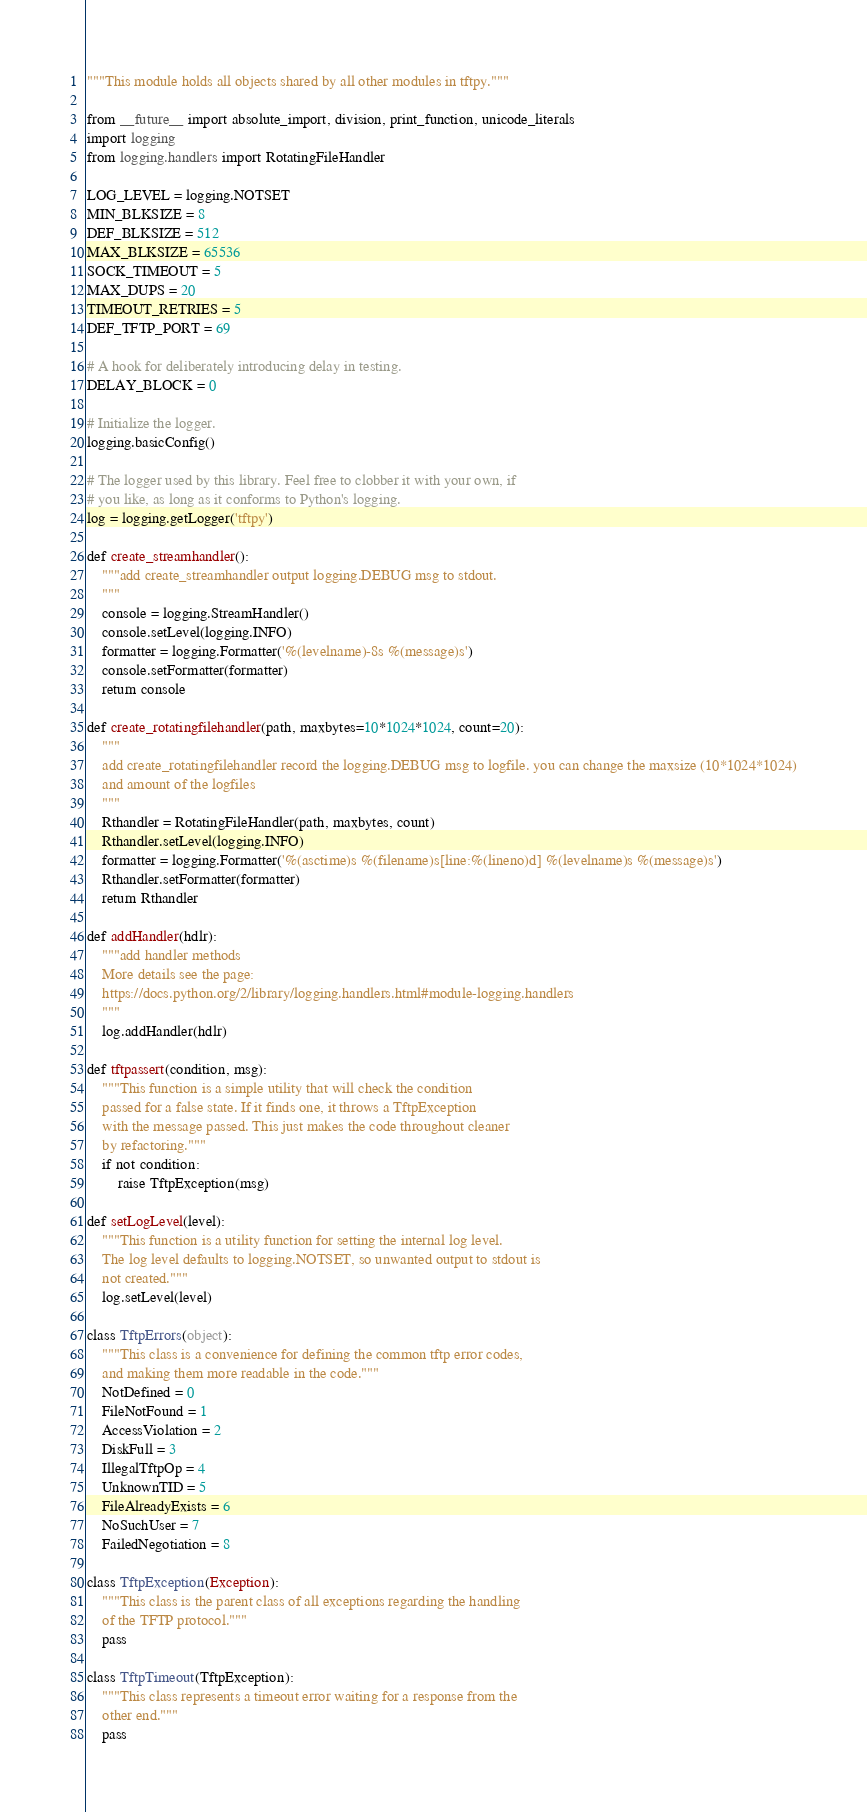Convert code to text. <code><loc_0><loc_0><loc_500><loc_500><_Python_>"""This module holds all objects shared by all other modules in tftpy."""

from __future__ import absolute_import, division, print_function, unicode_literals
import logging
from logging.handlers import RotatingFileHandler

LOG_LEVEL = logging.NOTSET
MIN_BLKSIZE = 8
DEF_BLKSIZE = 512
MAX_BLKSIZE = 65536
SOCK_TIMEOUT = 5
MAX_DUPS = 20
TIMEOUT_RETRIES = 5
DEF_TFTP_PORT = 69

# A hook for deliberately introducing delay in testing.
DELAY_BLOCK = 0

# Initialize the logger.
logging.basicConfig()

# The logger used by this library. Feel free to clobber it with your own, if
# you like, as long as it conforms to Python's logging.
log = logging.getLogger('tftpy')

def create_streamhandler():
    """add create_streamhandler output logging.DEBUG msg to stdout.
    """
    console = logging.StreamHandler()
    console.setLevel(logging.INFO)
    formatter = logging.Formatter('%(levelname)-8s %(message)s')
    console.setFormatter(formatter)
    return console

def create_rotatingfilehandler(path, maxbytes=10*1024*1024, count=20):
    """
    add create_rotatingfilehandler record the logging.DEBUG msg to logfile. you can change the maxsize (10*1024*1024)
    and amount of the logfiles
    """
    Rthandler = RotatingFileHandler(path, maxbytes, count)
    Rthandler.setLevel(logging.INFO)
    formatter = logging.Formatter('%(asctime)s %(filename)s[line:%(lineno)d] %(levelname)s %(message)s')
    Rthandler.setFormatter(formatter)
    return Rthandler

def addHandler(hdlr):
    """add handler methods
    More details see the page:
    https://docs.python.org/2/library/logging.handlers.html#module-logging.handlers
    """
    log.addHandler(hdlr)

def tftpassert(condition, msg):
    """This function is a simple utility that will check the condition
    passed for a false state. If it finds one, it throws a TftpException
    with the message passed. This just makes the code throughout cleaner
    by refactoring."""
    if not condition:
        raise TftpException(msg)

def setLogLevel(level):
    """This function is a utility function for setting the internal log level.
    The log level defaults to logging.NOTSET, so unwanted output to stdout is
    not created."""
    log.setLevel(level)

class TftpErrors(object):
    """This class is a convenience for defining the common tftp error codes,
    and making them more readable in the code."""
    NotDefined = 0
    FileNotFound = 1
    AccessViolation = 2
    DiskFull = 3
    IllegalTftpOp = 4
    UnknownTID = 5
    FileAlreadyExists = 6
    NoSuchUser = 7
    FailedNegotiation = 8

class TftpException(Exception):
    """This class is the parent class of all exceptions regarding the handling
    of the TFTP protocol."""
    pass

class TftpTimeout(TftpException):
    """This class represents a timeout error waiting for a response from the
    other end."""
    pass
</code> 